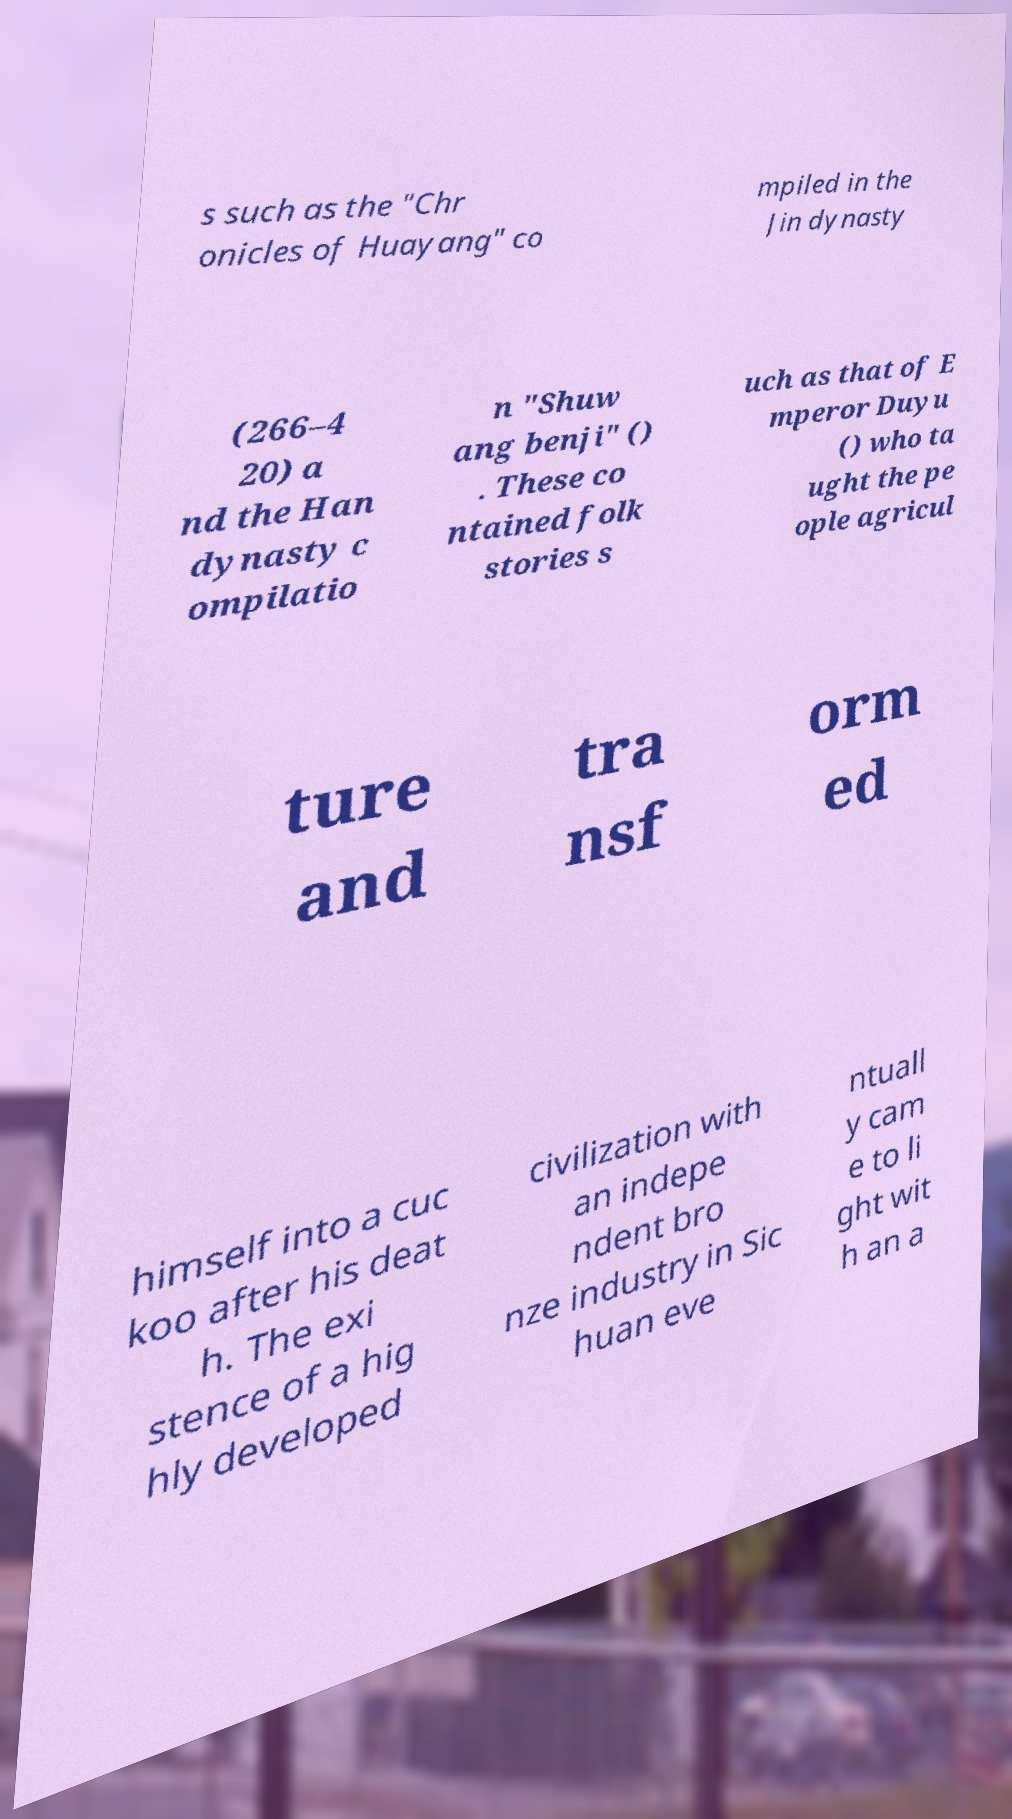I need the written content from this picture converted into text. Can you do that? s such as the "Chr onicles of Huayang" co mpiled in the Jin dynasty (266–4 20) a nd the Han dynasty c ompilatio n "Shuw ang benji" () . These co ntained folk stories s uch as that of E mperor Duyu () who ta ught the pe ople agricul ture and tra nsf orm ed himself into a cuc koo after his deat h. The exi stence of a hig hly developed civilization with an indepe ndent bro nze industry in Sic huan eve ntuall y cam e to li ght wit h an a 